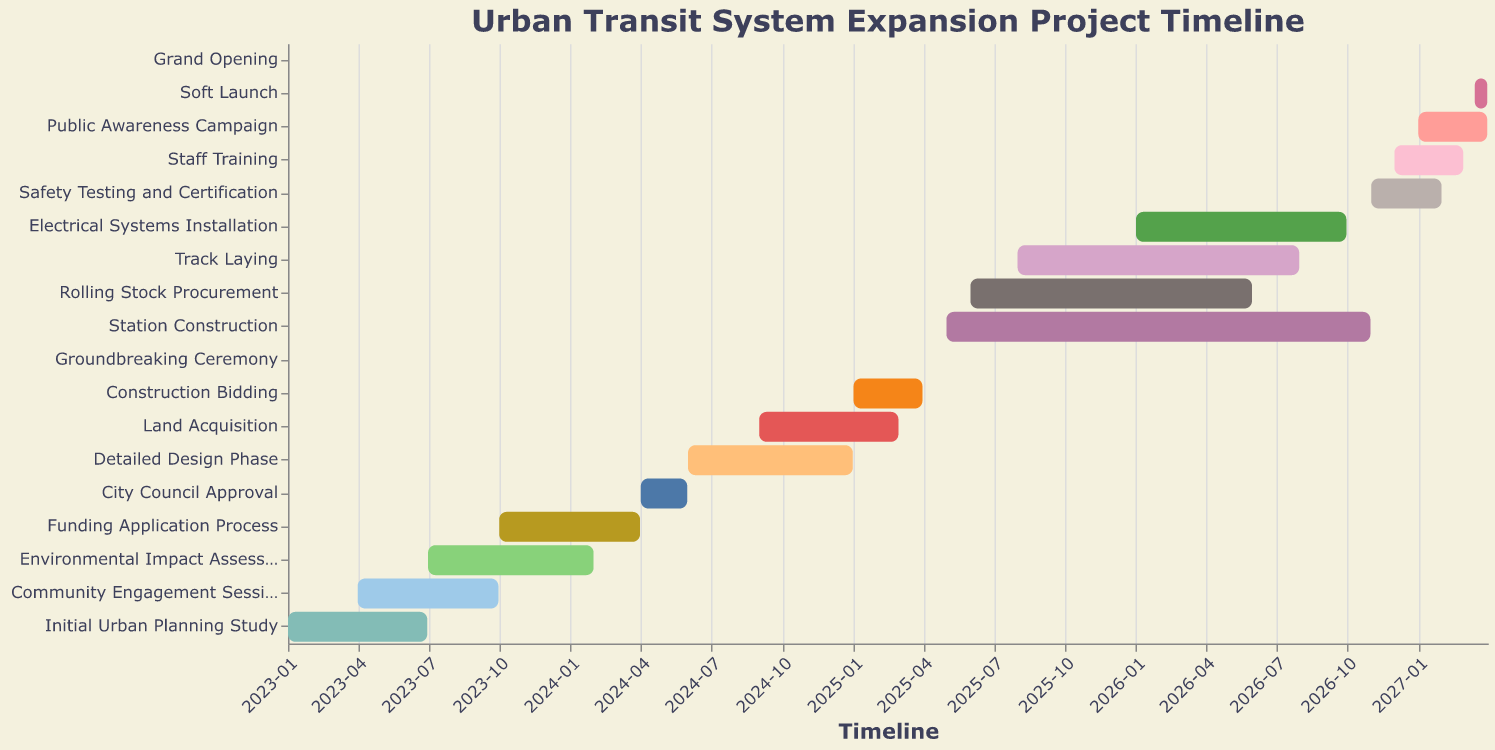What is the title of the Gantt Chart? The title of the Gantt Chart can be found at the top of the figure. It usually provides a short description of what the chart represents. In this case, it is mentioned in the code provided.
Answer: Urban Transit System Expansion Project Timeline Which task starts first in the project timeline? By looking at the earliest date on the x-axis and finding the task that aligns with it, we see that "Initial Urban Planning Study" starts first.
Answer: Initial Urban Planning Study How long does the Construction Bidding phase last? To determine the duration of the "Construction Bidding" phase, we need to calculate the difference between its end date (2025-03-31) and start date (2025-01-01). By counting the months: January to March is 3 months.
Answer: 3 months Which task has the shortest duration? To find the task with the shortest duration, we look for the task bar that spans the smallest width on the x-axis. The "Groundbreaking Ceremony" is a single-day event, lasting from 2025-04-15 to 2025-04-15.
Answer: Groundbreaking Ceremony What is the primary color scheme of the Gantt Chart? The color scheme used in the Gantt chart is specified in the code with “scheme” as "tableau20." This palette consists of distinct and bright colors for visual clarity.
Answer: Tableau 20 During which phases does the "Environmental Impact Assessment" overlap with the "Community Engagement Sessions"? To determine overlap, identify the start and end dates of both tasks. "Community Engagement Sessions" run from 2023-04-01 to 2023-09-30 and "Environmental Impact Assessment" goes from 2023-07-01 to 2024-01-31. The overlapping period is from 2023-07-01 to 2023-09-30.
Answer: July 2023 to September 2023 Which task occurs immediately before the "Grand Opening"? By checking the tasks and their end dates, we find that the "Soft Launch" ends on 2027-03-31, right before the "Grand Opening" on 2027-04-01.
Answer: Soft Launch Are there any tasks that span more than one year? We need to look for tasks that start in one year and end in a different year. "Environmental Impact Assessment," "Funding Application Process," "Detailed Design Phase," "Station Construction," "Track Laying," "Electrical Systems Installation," "Rolling Stock Procurement," "Safety Testing and Certification," and "Staff Training" all span multiple years.
Answer: Yes What phases are part of the actual construction of the transit system? Identifying the construction-specific tasks involves finding related activities. "Station Construction," "Track Laying," "Electrical Systems Installation," and "Safety Testing and Certification" are all part of the construction.
Answer: Station Construction, Track Laying, Electrical Systems Installation, Safety Testing and Certification What is the total duration from the start of the "Initial Urban Planning Study" to the "Grand Opening"? Calculate the difference between the start date of the "Initial Urban Planning Study" (2023-01-01) and the "Grand Opening" date (2027-04-01). The duration spans from January 2023 to April 2027, which totals 4 years and 3 months (51 months).
Answer: 4 years and 3 months 